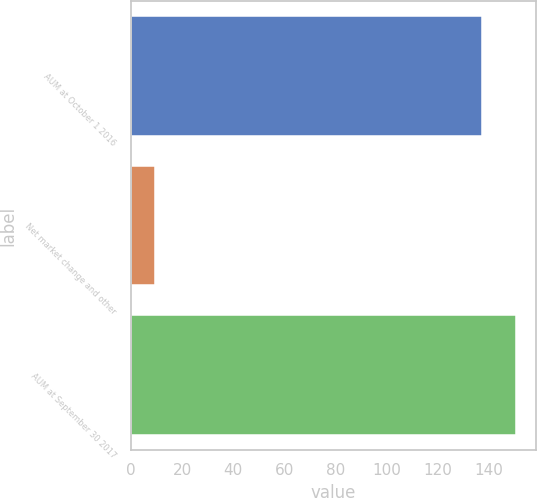Convert chart to OTSL. <chart><loc_0><loc_0><loc_500><loc_500><bar_chart><fcel>AUM at October 1 2016<fcel>Net market change and other<fcel>AUM at September 30 2017<nl><fcel>137.4<fcel>9.3<fcel>150.8<nl></chart> 